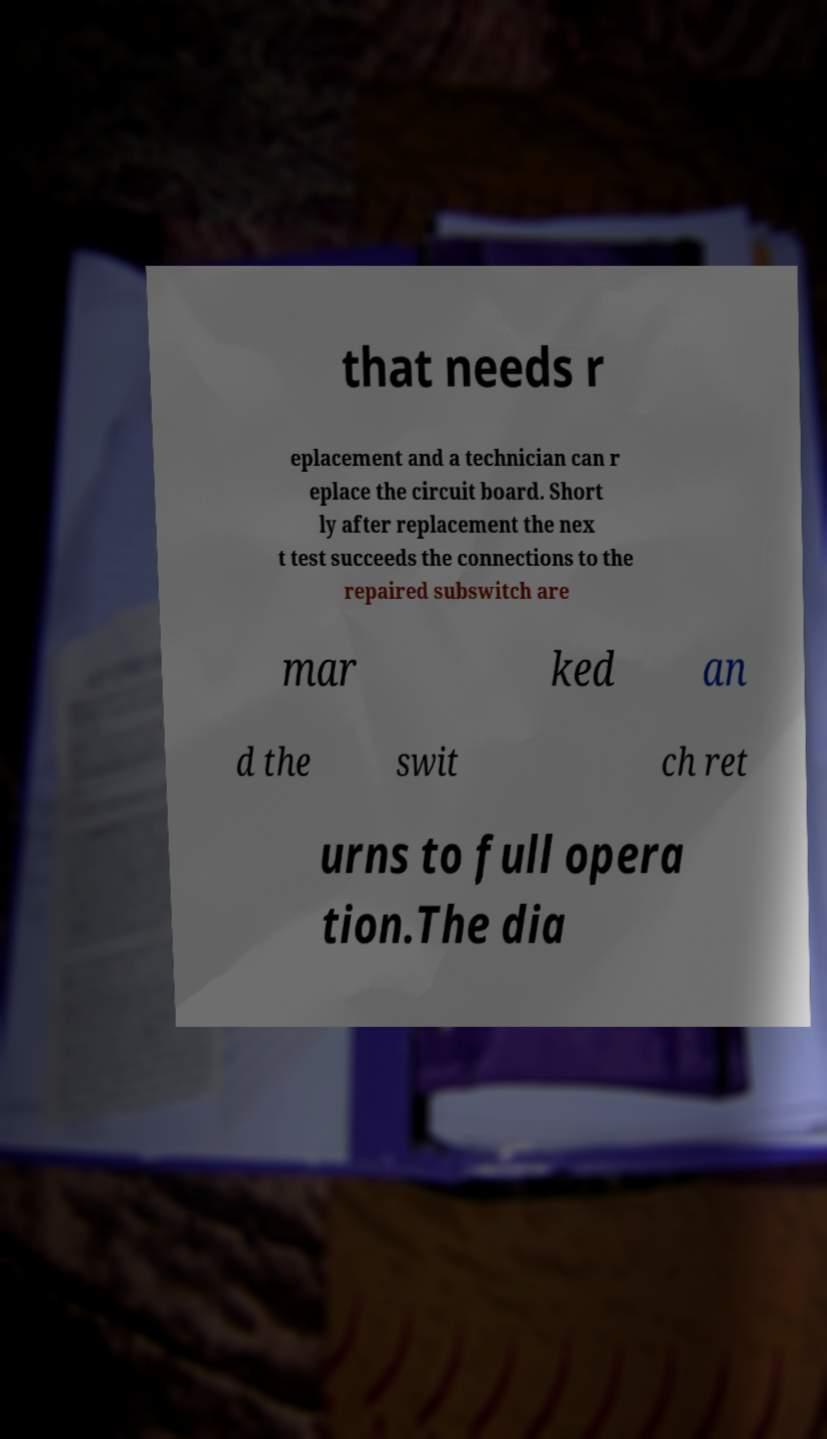Could you extract and type out the text from this image? that needs r eplacement and a technician can r eplace the circuit board. Short ly after replacement the nex t test succeeds the connections to the repaired subswitch are mar ked an d the swit ch ret urns to full opera tion.The dia 